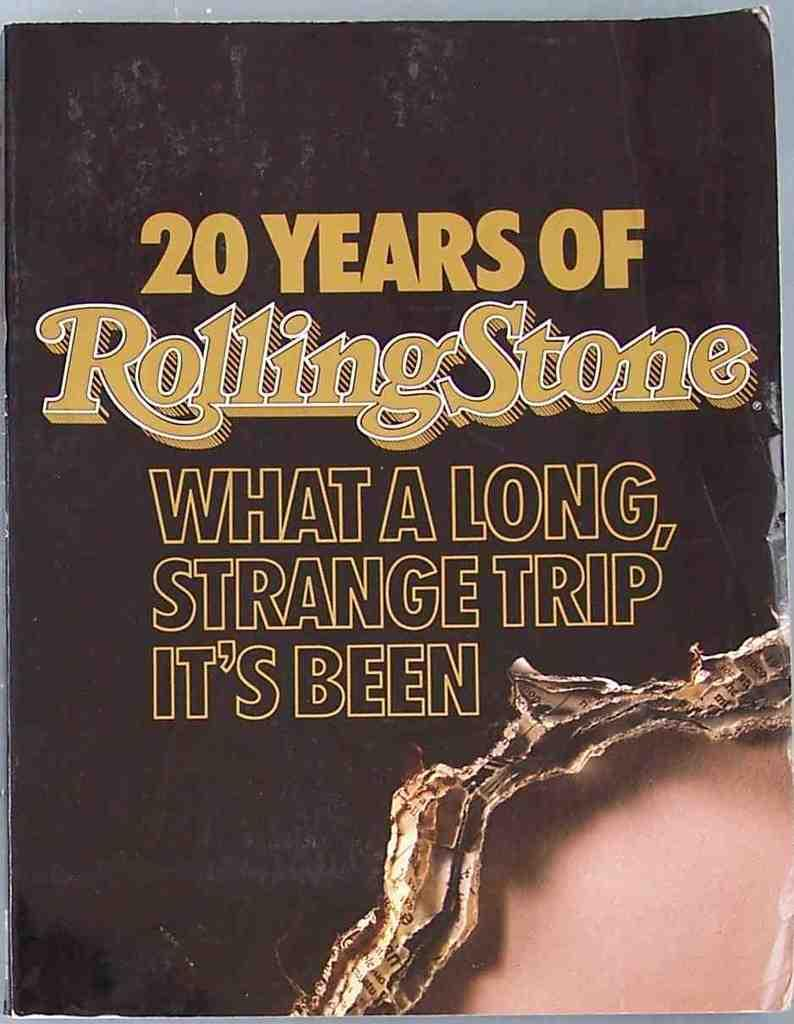<image>
Provide a brief description of the given image. A book cover appears to be ripped and is titled 20 Years of Rolling Stone. 